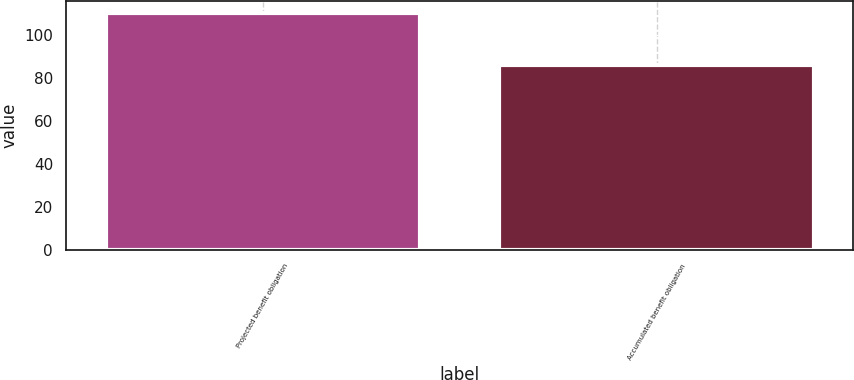<chart> <loc_0><loc_0><loc_500><loc_500><bar_chart><fcel>Projected benefit obligation<fcel>Accumulated benefit obligation<nl><fcel>110.3<fcel>86.1<nl></chart> 